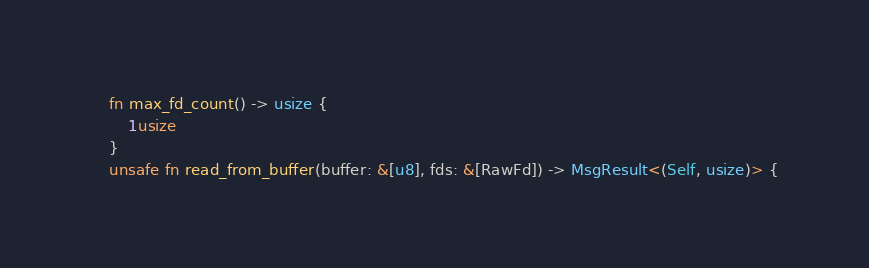Convert code to text. <code><loc_0><loc_0><loc_500><loc_500><_Rust_>    fn max_fd_count() -> usize {
        1usize
    }
    unsafe fn read_from_buffer(buffer: &[u8], fds: &[RawFd]) -> MsgResult<(Self, usize)> {</code> 